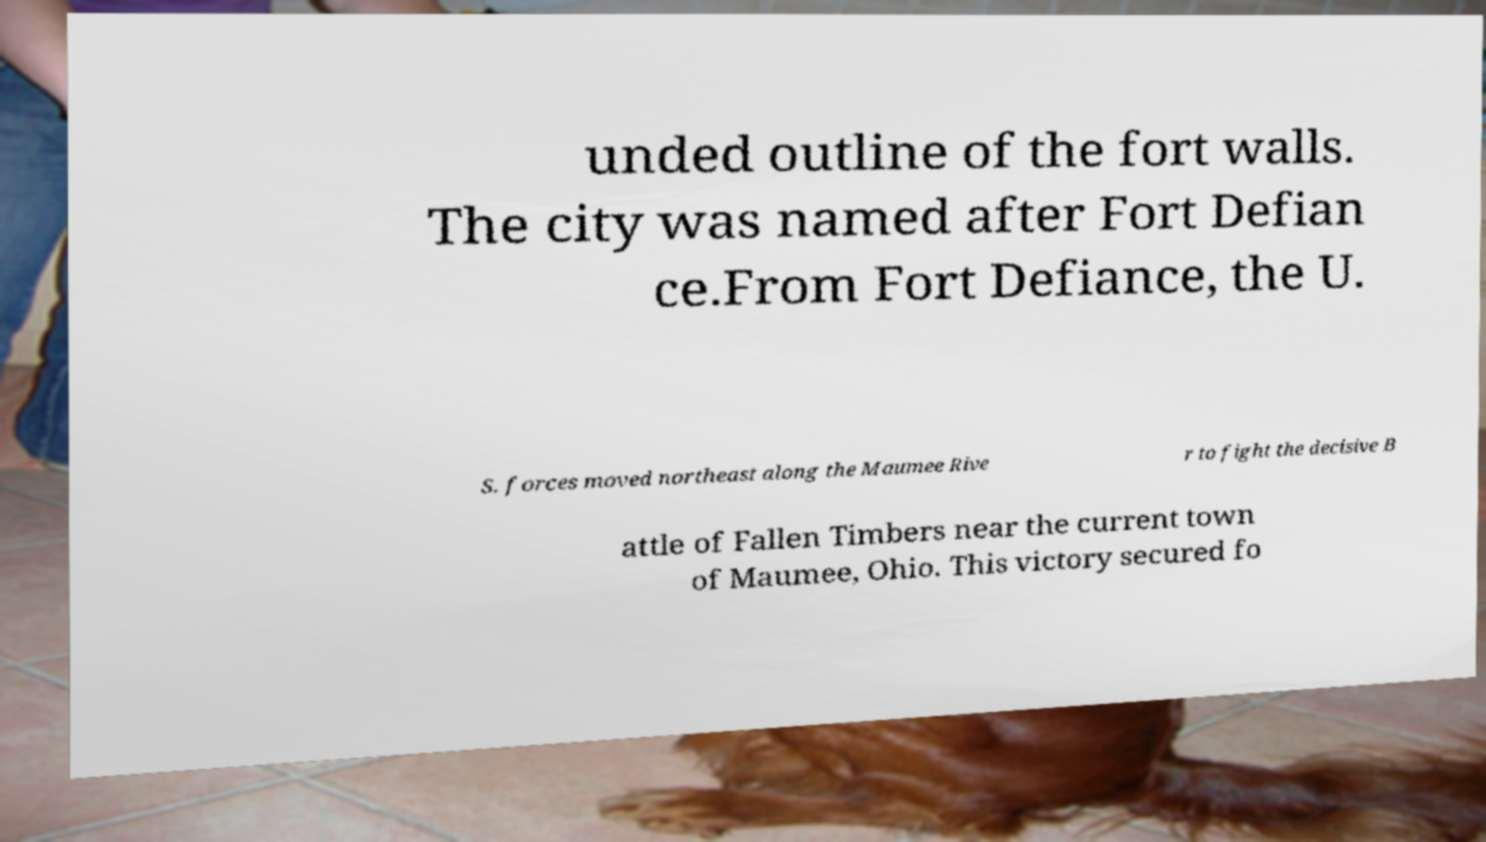There's text embedded in this image that I need extracted. Can you transcribe it verbatim? unded outline of the fort walls. The city was named after Fort Defian ce.From Fort Defiance, the U. S. forces moved northeast along the Maumee Rive r to fight the decisive B attle of Fallen Timbers near the current town of Maumee, Ohio. This victory secured fo 